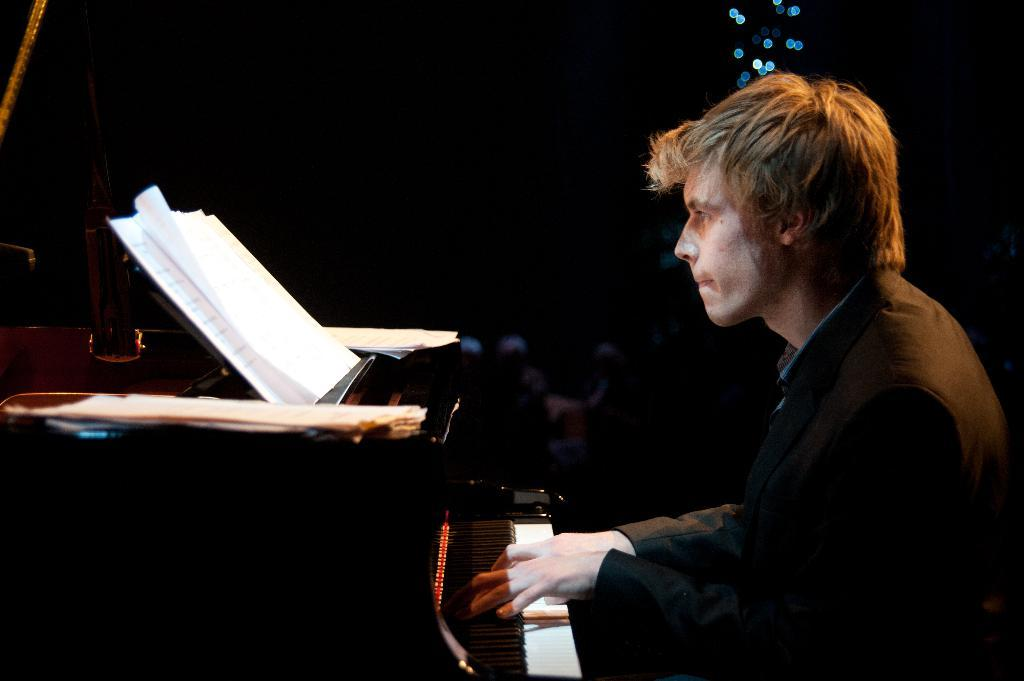What is the person in the image doing? The person is playing a piano. What might be the purpose of the musical notes in front of the person? The musical notes are likely being used as a guide or reference for the person playing the piano. Can you describe the person's activity in the image? The person is sitting at a piano and using their hands to press the keys, creating musical notes. What organization is responsible for the thing in front of the person? There is no "thing" mentioned in the facts, and no organization is responsible for the musical notes in front of the person. 